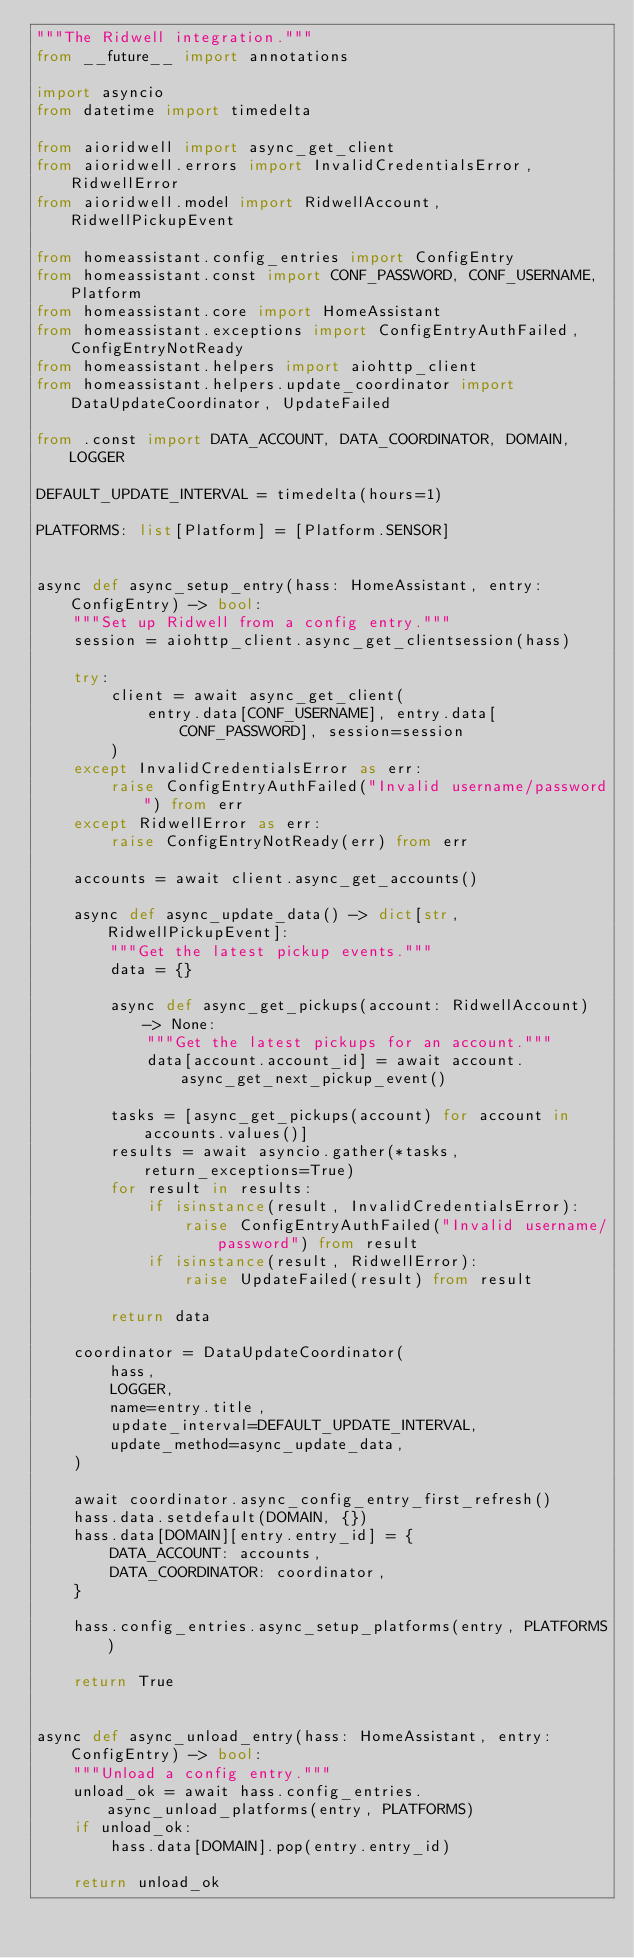Convert code to text. <code><loc_0><loc_0><loc_500><loc_500><_Python_>"""The Ridwell integration."""
from __future__ import annotations

import asyncio
from datetime import timedelta

from aioridwell import async_get_client
from aioridwell.errors import InvalidCredentialsError, RidwellError
from aioridwell.model import RidwellAccount, RidwellPickupEvent

from homeassistant.config_entries import ConfigEntry
from homeassistant.const import CONF_PASSWORD, CONF_USERNAME, Platform
from homeassistant.core import HomeAssistant
from homeassistant.exceptions import ConfigEntryAuthFailed, ConfigEntryNotReady
from homeassistant.helpers import aiohttp_client
from homeassistant.helpers.update_coordinator import DataUpdateCoordinator, UpdateFailed

from .const import DATA_ACCOUNT, DATA_COORDINATOR, DOMAIN, LOGGER

DEFAULT_UPDATE_INTERVAL = timedelta(hours=1)

PLATFORMS: list[Platform] = [Platform.SENSOR]


async def async_setup_entry(hass: HomeAssistant, entry: ConfigEntry) -> bool:
    """Set up Ridwell from a config entry."""
    session = aiohttp_client.async_get_clientsession(hass)

    try:
        client = await async_get_client(
            entry.data[CONF_USERNAME], entry.data[CONF_PASSWORD], session=session
        )
    except InvalidCredentialsError as err:
        raise ConfigEntryAuthFailed("Invalid username/password") from err
    except RidwellError as err:
        raise ConfigEntryNotReady(err) from err

    accounts = await client.async_get_accounts()

    async def async_update_data() -> dict[str, RidwellPickupEvent]:
        """Get the latest pickup events."""
        data = {}

        async def async_get_pickups(account: RidwellAccount) -> None:
            """Get the latest pickups for an account."""
            data[account.account_id] = await account.async_get_next_pickup_event()

        tasks = [async_get_pickups(account) for account in accounts.values()]
        results = await asyncio.gather(*tasks, return_exceptions=True)
        for result in results:
            if isinstance(result, InvalidCredentialsError):
                raise ConfigEntryAuthFailed("Invalid username/password") from result
            if isinstance(result, RidwellError):
                raise UpdateFailed(result) from result

        return data

    coordinator = DataUpdateCoordinator(
        hass,
        LOGGER,
        name=entry.title,
        update_interval=DEFAULT_UPDATE_INTERVAL,
        update_method=async_update_data,
    )

    await coordinator.async_config_entry_first_refresh()
    hass.data.setdefault(DOMAIN, {})
    hass.data[DOMAIN][entry.entry_id] = {
        DATA_ACCOUNT: accounts,
        DATA_COORDINATOR: coordinator,
    }

    hass.config_entries.async_setup_platforms(entry, PLATFORMS)

    return True


async def async_unload_entry(hass: HomeAssistant, entry: ConfigEntry) -> bool:
    """Unload a config entry."""
    unload_ok = await hass.config_entries.async_unload_platforms(entry, PLATFORMS)
    if unload_ok:
        hass.data[DOMAIN].pop(entry.entry_id)

    return unload_ok
</code> 